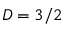<formula> <loc_0><loc_0><loc_500><loc_500>D = 3 / 2</formula> 